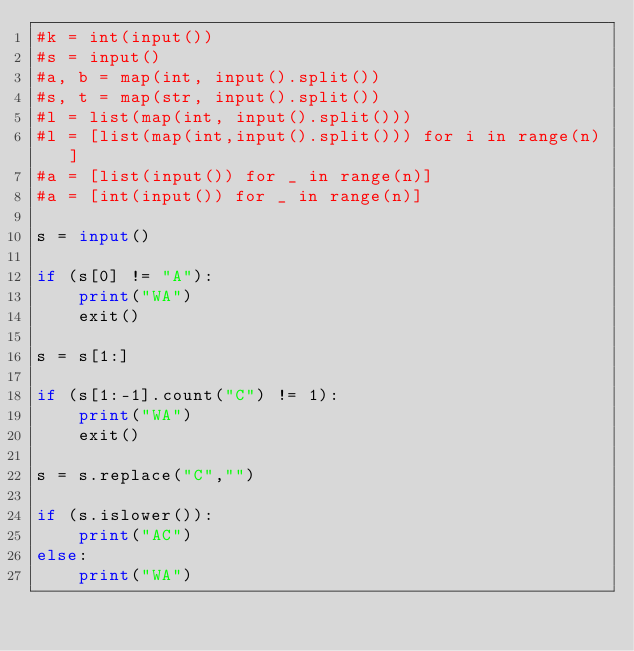Convert code to text. <code><loc_0><loc_0><loc_500><loc_500><_Python_>#k = int(input())
#s = input()
#a, b = map(int, input().split())
#s, t = map(str, input().split())
#l = list(map(int, input().split()))
#l = [list(map(int,input().split())) for i in range(n)]
#a = [list(input()) for _ in range(n)]
#a = [int(input()) for _ in range(n)]

s = input()

if (s[0] != "A"):
    print("WA")
    exit()

s = s[1:]

if (s[1:-1].count("C") != 1):
    print("WA")
    exit()

s = s.replace("C","")

if (s.islower()):
    print("AC")
else:
    print("WA")


</code> 